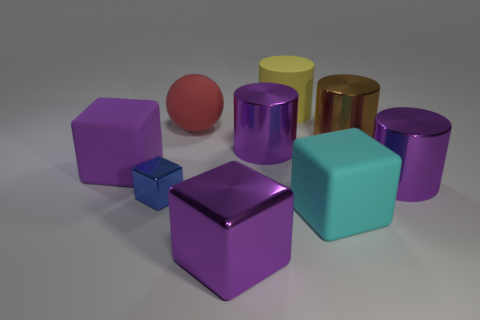Are there any yellow rubber things in front of the small object?
Provide a succinct answer. No. Is the matte cylinder the same size as the blue shiny object?
Offer a terse response. No. The other metallic thing that is the same shape as the tiny blue metallic thing is what size?
Give a very brief answer. Large. Is there any other thing that has the same size as the blue block?
Provide a succinct answer. No. There is a big cylinder that is behind the brown metal object in front of the rubber ball; what is it made of?
Offer a terse response. Rubber. Does the purple rubber object have the same shape as the tiny metallic thing?
Keep it short and to the point. Yes. How many large things are in front of the large yellow matte cylinder and on the right side of the big purple rubber cube?
Give a very brief answer. 6. Is the number of blue metal objects behind the small cube the same as the number of shiny things that are to the left of the big cyan rubber block?
Make the answer very short. No. Do the purple cylinder that is right of the big cyan thing and the red rubber ball left of the yellow thing have the same size?
Make the answer very short. Yes. There is a large block that is behind the large metal block and to the right of the small cube; what material is it?
Your response must be concise. Rubber. 